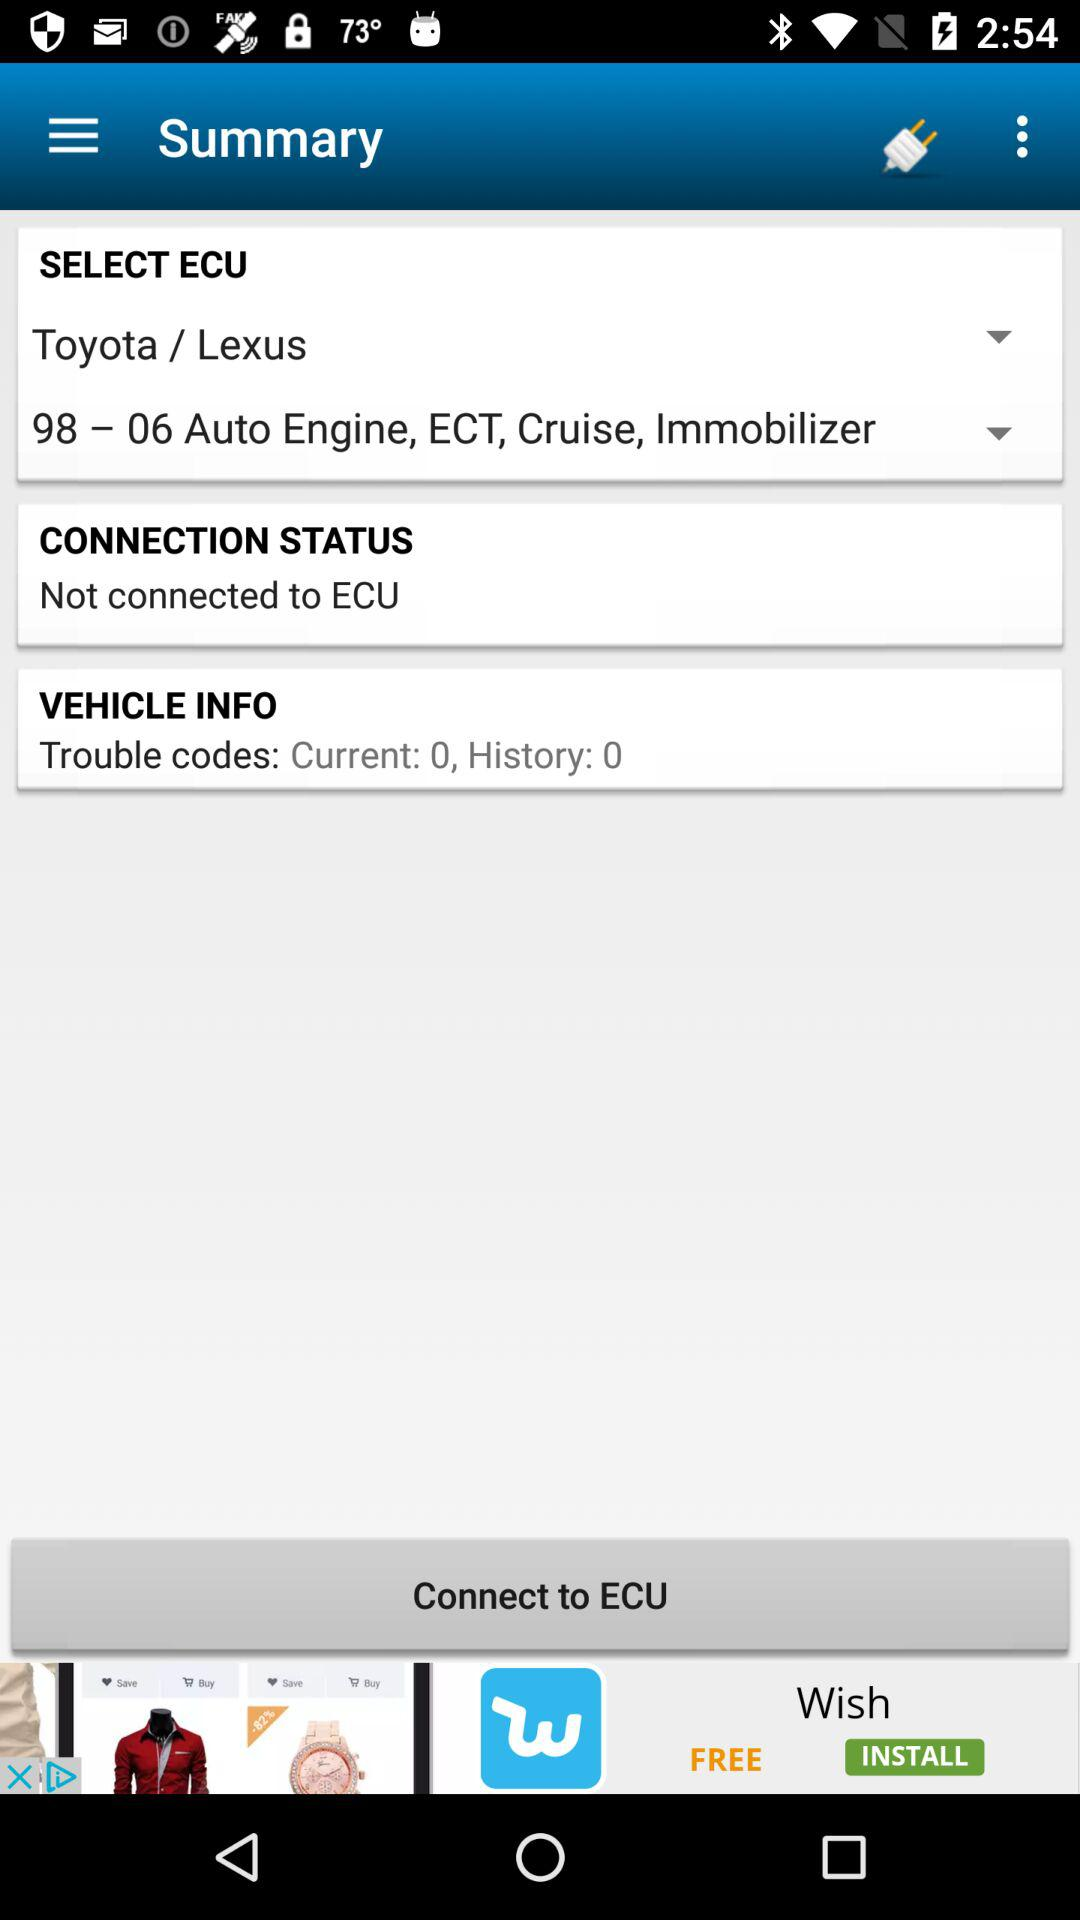What are the features of the Toyota/Lexus? The features of the Toyota/Lexus are 98–06 Auto Engine, ECT, Cruise and Immobilizer. 